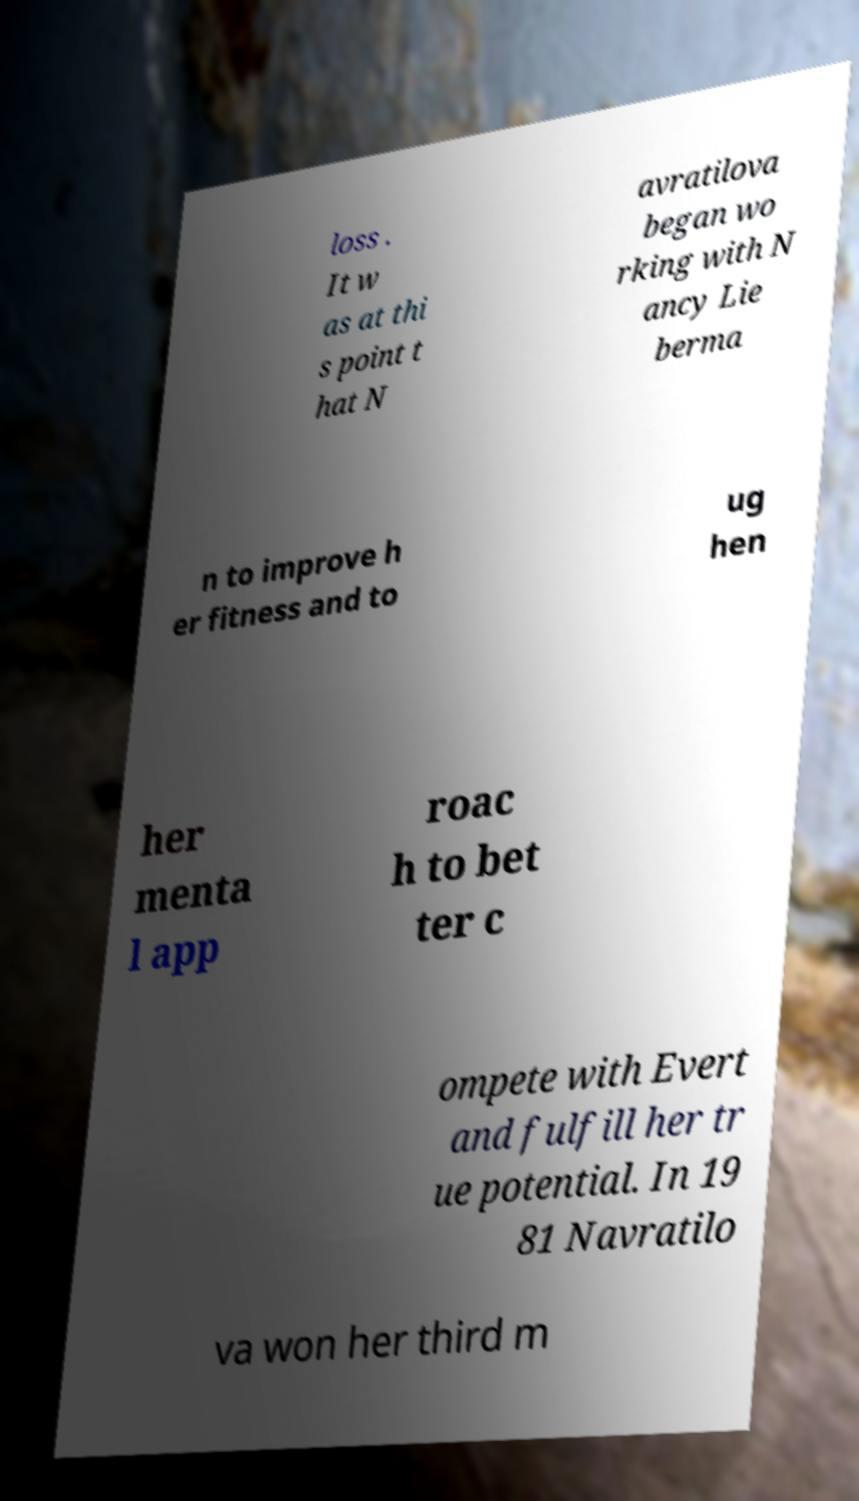Please read and relay the text visible in this image. What does it say? loss . It w as at thi s point t hat N avratilova began wo rking with N ancy Lie berma n to improve h er fitness and to ug hen her menta l app roac h to bet ter c ompete with Evert and fulfill her tr ue potential. In 19 81 Navratilo va won her third m 